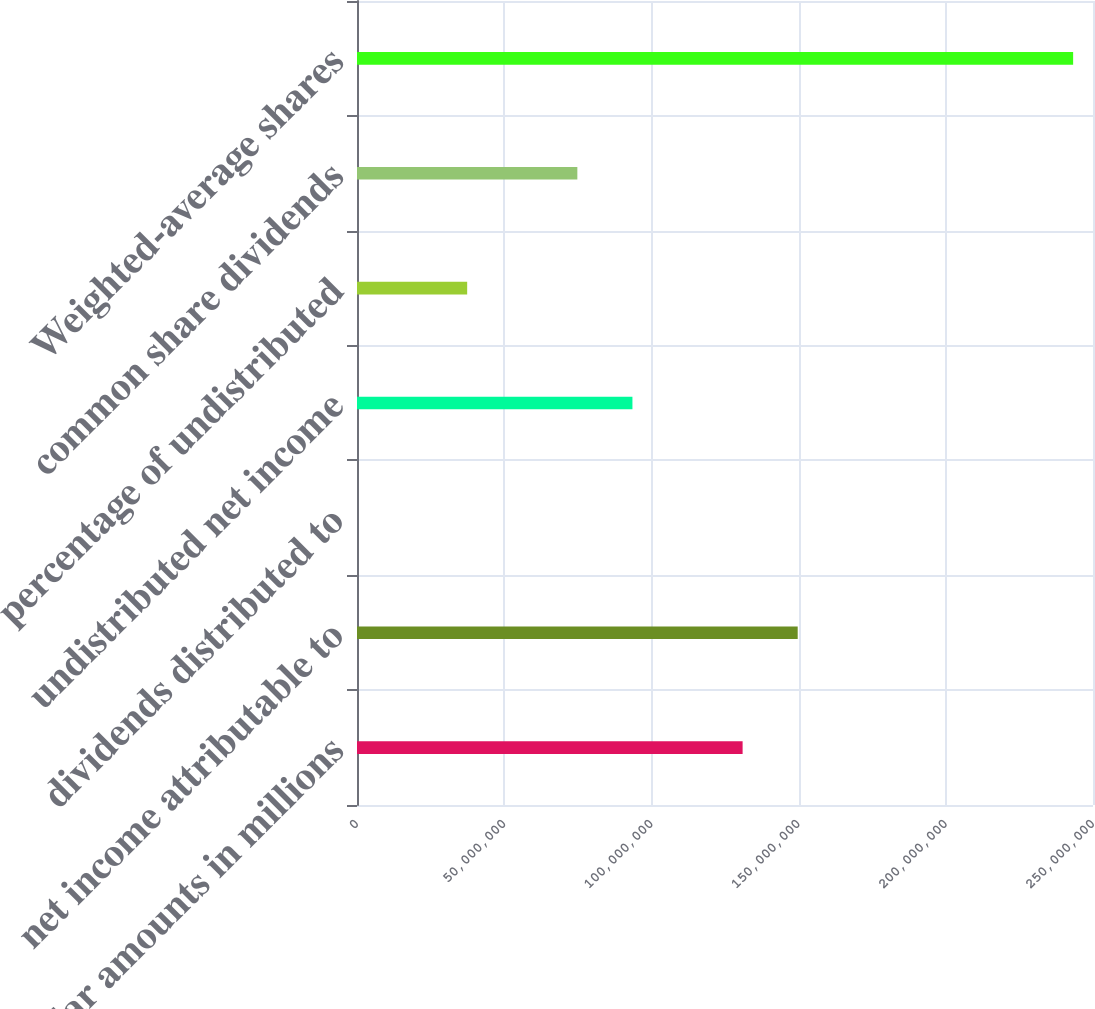<chart> <loc_0><loc_0><loc_500><loc_500><bar_chart><fcel>(Dollar amounts in millions<fcel>net income attributable to<fcel>dividends distributed to<fcel>undistributed net income<fcel>percentage of undistributed<fcel>common share dividends<fcel>Weighted-average shares<nl><fcel>1.30981e+08<fcel>1.49693e+08<fcel>10<fcel>9.35582e+07<fcel>3.74233e+07<fcel>7.48466e+07<fcel>2.43251e+08<nl></chart> 